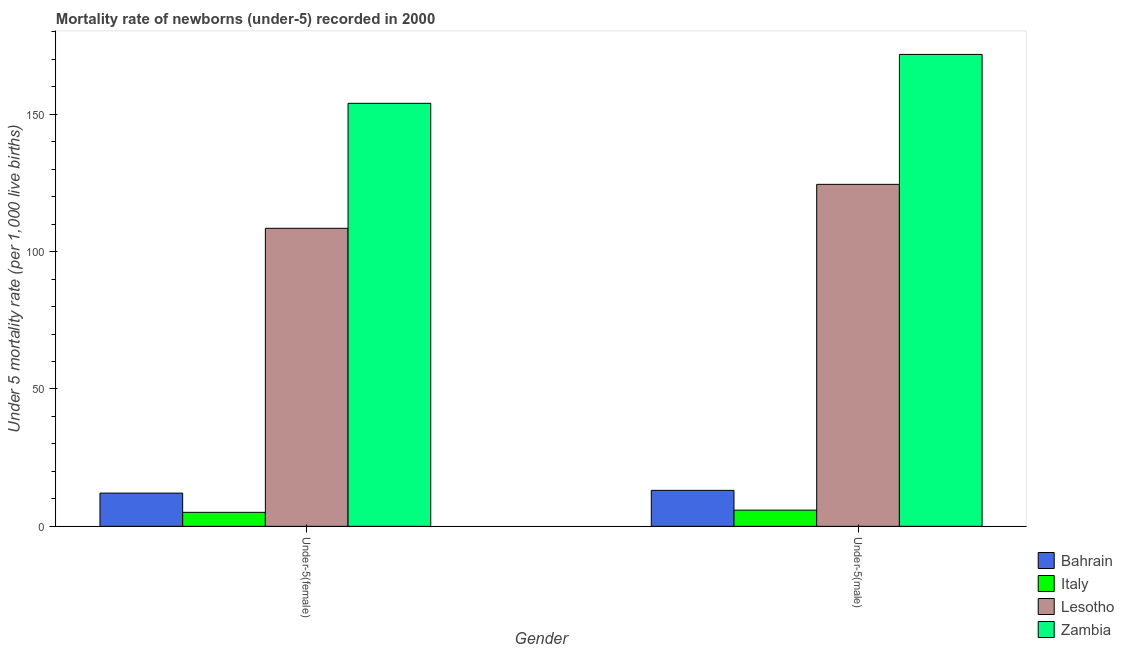Are the number of bars on each tick of the X-axis equal?
Keep it short and to the point. Yes. What is the label of the 2nd group of bars from the left?
Ensure brevity in your answer.  Under-5(male). What is the under-5 male mortality rate in Lesotho?
Provide a succinct answer. 124.5. Across all countries, what is the maximum under-5 female mortality rate?
Ensure brevity in your answer.  154. In which country was the under-5 female mortality rate maximum?
Offer a terse response. Zambia. In which country was the under-5 female mortality rate minimum?
Provide a short and direct response. Italy. What is the total under-5 female mortality rate in the graph?
Offer a terse response. 279.7. What is the difference between the under-5 female mortality rate in Italy and that in Lesotho?
Make the answer very short. -103.4. What is the difference between the under-5 female mortality rate in Zambia and the under-5 male mortality rate in Italy?
Ensure brevity in your answer.  148.1. What is the average under-5 male mortality rate per country?
Your response must be concise. 78.83. What is the difference between the under-5 male mortality rate and under-5 female mortality rate in Zambia?
Give a very brief answer. 17.8. What is the ratio of the under-5 male mortality rate in Bahrain to that in Italy?
Provide a succinct answer. 2.22. Is the under-5 male mortality rate in Italy less than that in Bahrain?
Offer a terse response. Yes. In how many countries, is the under-5 female mortality rate greater than the average under-5 female mortality rate taken over all countries?
Keep it short and to the point. 2. What does the 1st bar from the left in Under-5(male) represents?
Your answer should be very brief. Bahrain. What does the 1st bar from the right in Under-5(female) represents?
Give a very brief answer. Zambia. How many bars are there?
Make the answer very short. 8. What is the difference between two consecutive major ticks on the Y-axis?
Provide a succinct answer. 50. Are the values on the major ticks of Y-axis written in scientific E-notation?
Your answer should be very brief. No. Does the graph contain grids?
Offer a very short reply. No. How are the legend labels stacked?
Your response must be concise. Vertical. What is the title of the graph?
Keep it short and to the point. Mortality rate of newborns (under-5) recorded in 2000. Does "Namibia" appear as one of the legend labels in the graph?
Make the answer very short. No. What is the label or title of the Y-axis?
Offer a very short reply. Under 5 mortality rate (per 1,0 live births). What is the Under 5 mortality rate (per 1,000 live births) of Bahrain in Under-5(female)?
Provide a short and direct response. 12.1. What is the Under 5 mortality rate (per 1,000 live births) of Lesotho in Under-5(female)?
Keep it short and to the point. 108.5. What is the Under 5 mortality rate (per 1,000 live births) in Zambia in Under-5(female)?
Ensure brevity in your answer.  154. What is the Under 5 mortality rate (per 1,000 live births) in Bahrain in Under-5(male)?
Your answer should be very brief. 13.1. What is the Under 5 mortality rate (per 1,000 live births) of Lesotho in Under-5(male)?
Offer a very short reply. 124.5. What is the Under 5 mortality rate (per 1,000 live births) of Zambia in Under-5(male)?
Offer a very short reply. 171.8. Across all Gender, what is the maximum Under 5 mortality rate (per 1,000 live births) of Bahrain?
Make the answer very short. 13.1. Across all Gender, what is the maximum Under 5 mortality rate (per 1,000 live births) of Italy?
Make the answer very short. 5.9. Across all Gender, what is the maximum Under 5 mortality rate (per 1,000 live births) of Lesotho?
Offer a terse response. 124.5. Across all Gender, what is the maximum Under 5 mortality rate (per 1,000 live births) of Zambia?
Give a very brief answer. 171.8. Across all Gender, what is the minimum Under 5 mortality rate (per 1,000 live births) of Bahrain?
Provide a short and direct response. 12.1. Across all Gender, what is the minimum Under 5 mortality rate (per 1,000 live births) in Lesotho?
Offer a very short reply. 108.5. Across all Gender, what is the minimum Under 5 mortality rate (per 1,000 live births) in Zambia?
Your answer should be very brief. 154. What is the total Under 5 mortality rate (per 1,000 live births) of Bahrain in the graph?
Make the answer very short. 25.2. What is the total Under 5 mortality rate (per 1,000 live births) of Lesotho in the graph?
Your response must be concise. 233. What is the total Under 5 mortality rate (per 1,000 live births) of Zambia in the graph?
Offer a very short reply. 325.8. What is the difference between the Under 5 mortality rate (per 1,000 live births) of Bahrain in Under-5(female) and that in Under-5(male)?
Ensure brevity in your answer.  -1. What is the difference between the Under 5 mortality rate (per 1,000 live births) of Italy in Under-5(female) and that in Under-5(male)?
Provide a short and direct response. -0.8. What is the difference between the Under 5 mortality rate (per 1,000 live births) in Zambia in Under-5(female) and that in Under-5(male)?
Your answer should be very brief. -17.8. What is the difference between the Under 5 mortality rate (per 1,000 live births) of Bahrain in Under-5(female) and the Under 5 mortality rate (per 1,000 live births) of Lesotho in Under-5(male)?
Provide a succinct answer. -112.4. What is the difference between the Under 5 mortality rate (per 1,000 live births) in Bahrain in Under-5(female) and the Under 5 mortality rate (per 1,000 live births) in Zambia in Under-5(male)?
Provide a short and direct response. -159.7. What is the difference between the Under 5 mortality rate (per 1,000 live births) in Italy in Under-5(female) and the Under 5 mortality rate (per 1,000 live births) in Lesotho in Under-5(male)?
Provide a succinct answer. -119.4. What is the difference between the Under 5 mortality rate (per 1,000 live births) of Italy in Under-5(female) and the Under 5 mortality rate (per 1,000 live births) of Zambia in Under-5(male)?
Your response must be concise. -166.7. What is the difference between the Under 5 mortality rate (per 1,000 live births) of Lesotho in Under-5(female) and the Under 5 mortality rate (per 1,000 live births) of Zambia in Under-5(male)?
Your answer should be very brief. -63.3. What is the average Under 5 mortality rate (per 1,000 live births) in Bahrain per Gender?
Offer a very short reply. 12.6. What is the average Under 5 mortality rate (per 1,000 live births) in Italy per Gender?
Offer a very short reply. 5.5. What is the average Under 5 mortality rate (per 1,000 live births) in Lesotho per Gender?
Make the answer very short. 116.5. What is the average Under 5 mortality rate (per 1,000 live births) of Zambia per Gender?
Provide a short and direct response. 162.9. What is the difference between the Under 5 mortality rate (per 1,000 live births) of Bahrain and Under 5 mortality rate (per 1,000 live births) of Italy in Under-5(female)?
Your answer should be very brief. 7. What is the difference between the Under 5 mortality rate (per 1,000 live births) of Bahrain and Under 5 mortality rate (per 1,000 live births) of Lesotho in Under-5(female)?
Your answer should be very brief. -96.4. What is the difference between the Under 5 mortality rate (per 1,000 live births) of Bahrain and Under 5 mortality rate (per 1,000 live births) of Zambia in Under-5(female)?
Provide a succinct answer. -141.9. What is the difference between the Under 5 mortality rate (per 1,000 live births) of Italy and Under 5 mortality rate (per 1,000 live births) of Lesotho in Under-5(female)?
Your answer should be very brief. -103.4. What is the difference between the Under 5 mortality rate (per 1,000 live births) in Italy and Under 5 mortality rate (per 1,000 live births) in Zambia in Under-5(female)?
Ensure brevity in your answer.  -148.9. What is the difference between the Under 5 mortality rate (per 1,000 live births) of Lesotho and Under 5 mortality rate (per 1,000 live births) of Zambia in Under-5(female)?
Offer a very short reply. -45.5. What is the difference between the Under 5 mortality rate (per 1,000 live births) of Bahrain and Under 5 mortality rate (per 1,000 live births) of Lesotho in Under-5(male)?
Provide a succinct answer. -111.4. What is the difference between the Under 5 mortality rate (per 1,000 live births) in Bahrain and Under 5 mortality rate (per 1,000 live births) in Zambia in Under-5(male)?
Your answer should be compact. -158.7. What is the difference between the Under 5 mortality rate (per 1,000 live births) of Italy and Under 5 mortality rate (per 1,000 live births) of Lesotho in Under-5(male)?
Offer a very short reply. -118.6. What is the difference between the Under 5 mortality rate (per 1,000 live births) of Italy and Under 5 mortality rate (per 1,000 live births) of Zambia in Under-5(male)?
Your response must be concise. -165.9. What is the difference between the Under 5 mortality rate (per 1,000 live births) in Lesotho and Under 5 mortality rate (per 1,000 live births) in Zambia in Under-5(male)?
Keep it short and to the point. -47.3. What is the ratio of the Under 5 mortality rate (per 1,000 live births) in Bahrain in Under-5(female) to that in Under-5(male)?
Ensure brevity in your answer.  0.92. What is the ratio of the Under 5 mortality rate (per 1,000 live births) of Italy in Under-5(female) to that in Under-5(male)?
Offer a terse response. 0.86. What is the ratio of the Under 5 mortality rate (per 1,000 live births) in Lesotho in Under-5(female) to that in Under-5(male)?
Your answer should be compact. 0.87. What is the ratio of the Under 5 mortality rate (per 1,000 live births) of Zambia in Under-5(female) to that in Under-5(male)?
Your answer should be compact. 0.9. What is the difference between the highest and the second highest Under 5 mortality rate (per 1,000 live births) in Bahrain?
Make the answer very short. 1. What is the difference between the highest and the second highest Under 5 mortality rate (per 1,000 live births) in Lesotho?
Offer a terse response. 16. What is the difference between the highest and the second highest Under 5 mortality rate (per 1,000 live births) of Zambia?
Keep it short and to the point. 17.8. What is the difference between the highest and the lowest Under 5 mortality rate (per 1,000 live births) of Bahrain?
Your answer should be compact. 1. What is the difference between the highest and the lowest Under 5 mortality rate (per 1,000 live births) of Italy?
Your answer should be very brief. 0.8. What is the difference between the highest and the lowest Under 5 mortality rate (per 1,000 live births) of Lesotho?
Make the answer very short. 16. 